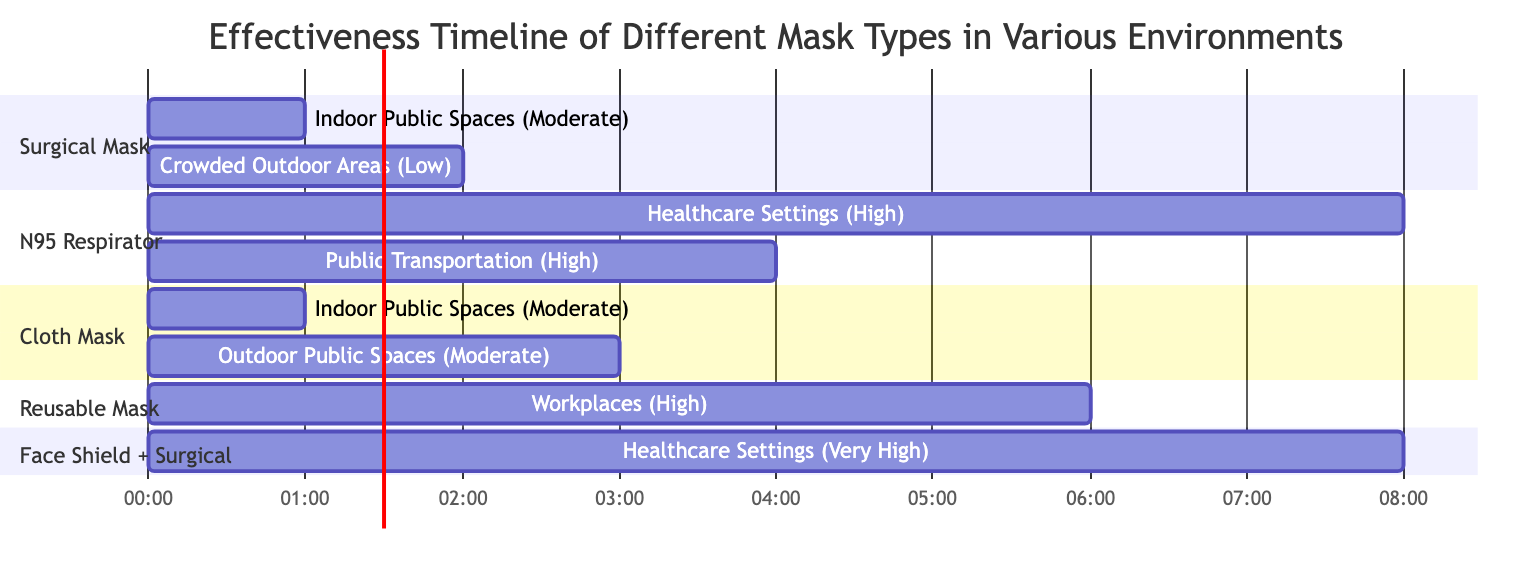What is the effectiveness of the Surgical Mask in Indoor Public Spaces? The diagram specifies that the Surgical Mask has a "Moderate" effectiveness in the Indoor Public Spaces section.
Answer: Moderate How long can a Face Shield combined with a Surgical Mask be effective in Healthcare Settings? According to the diagram, the Face Shield combined with a Surgical Mask is effective for "8 Hours" in the Healthcare Settings section.
Answer: 8 Hours How many mask types are shown in the diagram? The diagram includes five different mask types: Surgical Mask, N95 Respirator, Cloth Mask (Multiple Layers), Reusable Mask with PM2.5 Filters, and Face Shield combined with Surgical Mask.
Answer: 5 Which mask type has the longest duration of effectiveness in crowded outdoor areas? The diagram indicates that the Surgical Mask has a "2 Hours" duration in crowded outdoor areas, which is the longest specified for this environment.
Answer: Surgical Mask What is the effectiveness of the Reusable Mask with PM2.5 Filters in workplaces? The diagram states that the Reusable Mask with PM2.5 Filters has a "High" effectiveness in the Workplaces section.
Answer: High Which environment shows the highest effectiveness rating and for which mask type? The Face Shield combined with a Surgical Mask shows the highest effectiveness rating of "Very High" in Healthcare Settings.
Answer: Very High (Healthcare Settings) What is the total number of hours the N95 Respirator is effective in Public Transportation and Healthcare Settings combined? The N95 Respirator has durations of "4 Hours" in Public Transportation and "8 Hours" in Healthcare Settings. Adding these gives a total of 12 hours of effectiveness for the N95 Respirator in both environments.
Answer: 12 Hours How does the effectiveness of Cloth Masks in outdoor versus indoor public spaces compare according to the diagram? The diagram indicates that the effectiveness of Cloth Masks is "Moderate" for both Indoor Public Spaces (1 hour) and Outdoor Public Spaces (3 hours), showing they are equivalent in effectiveness but differ in duration.
Answer: Moderate (same) Which section includes a mask type that has an effectiveness of Low? The Crowded Outdoor Areas section includes the Surgical Mask, which is rated as having "Low" effectiveness.
Answer: Crowded Outdoor Areas 